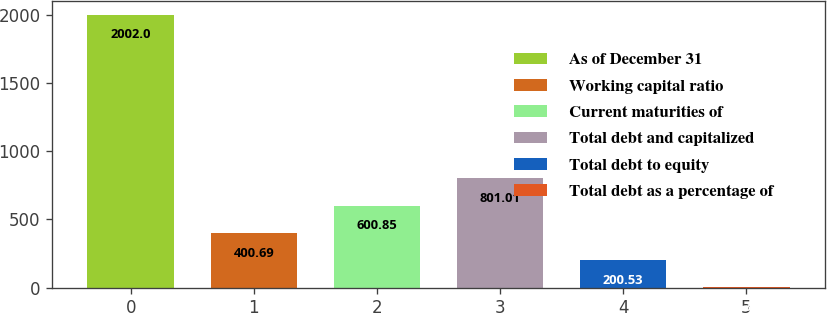Convert chart to OTSL. <chart><loc_0><loc_0><loc_500><loc_500><bar_chart><fcel>As of December 31<fcel>Working capital ratio<fcel>Current maturities of<fcel>Total debt and capitalized<fcel>Total debt to equity<fcel>Total debt as a percentage of<nl><fcel>2002<fcel>400.69<fcel>600.85<fcel>801.01<fcel>200.53<fcel>0.37<nl></chart> 